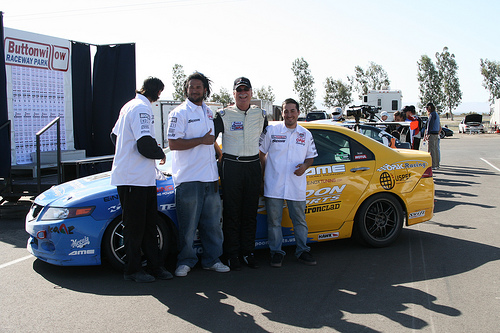<image>
Can you confirm if the man is behind the car? No. The man is not behind the car. From this viewpoint, the man appears to be positioned elsewhere in the scene. 